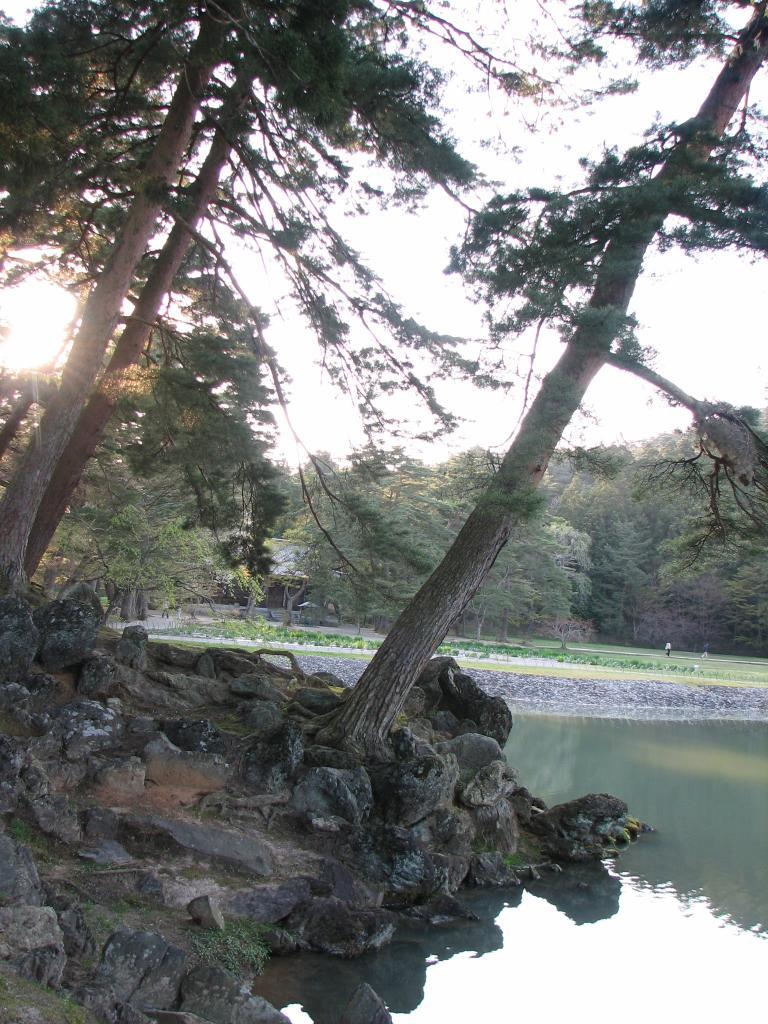What type of vegetation is on the left side of the image? There are trees on the left side of the image. What else is present on the left side of the image? There are stones on the left side of the image. What can be seen on the right side of the image? There is water on the right side of the image. What is visible in the background of the image? There are trees and the sky visible in the background of the image. What type of system is being used for the activity in the image? There is no activity or system present in the image; it features trees, stones, water, and a sky background. What body of water is visible in the image? There is no body of water visible in the image; it features water on the right side, but it is not specified as a body of water. 